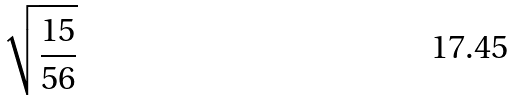<formula> <loc_0><loc_0><loc_500><loc_500>\sqrt { \frac { 1 5 } { 5 6 } }</formula> 